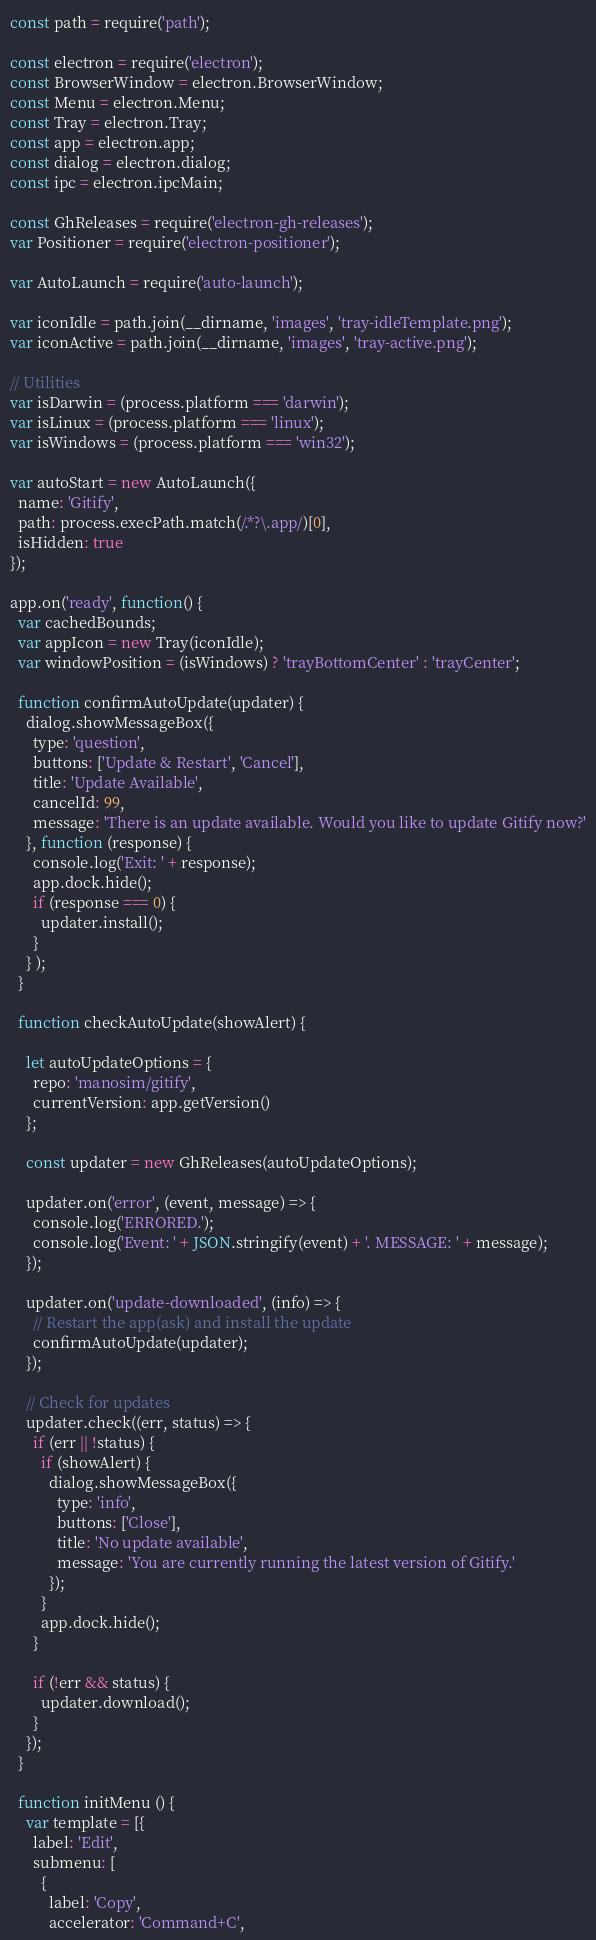Convert code to text. <code><loc_0><loc_0><loc_500><loc_500><_JavaScript_>const path = require('path');

const electron = require('electron');
const BrowserWindow = electron.BrowserWindow;
const Menu = electron.Menu;
const Tray = electron.Tray;
const app = electron.app;
const dialog = electron.dialog;
const ipc = electron.ipcMain;

const GhReleases = require('electron-gh-releases');
var Positioner = require('electron-positioner');

var AutoLaunch = require('auto-launch');

var iconIdle = path.join(__dirname, 'images', 'tray-idleTemplate.png');
var iconActive = path.join(__dirname, 'images', 'tray-active.png');

// Utilities
var isDarwin = (process.platform === 'darwin');
var isLinux = (process.platform === 'linux');
var isWindows = (process.platform === 'win32');

var autoStart = new AutoLaunch({
  name: 'Gitify',
  path: process.execPath.match(/.*?\.app/)[0],
  isHidden: true
});

app.on('ready', function() {
  var cachedBounds;
  var appIcon = new Tray(iconIdle);
  var windowPosition = (isWindows) ? 'trayBottomCenter' : 'trayCenter';

  function confirmAutoUpdate(updater) {
    dialog.showMessageBox({
      type: 'question',
      buttons: ['Update & Restart', 'Cancel'],
      title: 'Update Available',
      cancelId: 99,
      message: 'There is an update available. Would you like to update Gitify now?'
    }, function (response) {
      console.log('Exit: ' + response);
      app.dock.hide();
      if (response === 0) {
        updater.install();
      }
    } );
  }

  function checkAutoUpdate(showAlert) {

    let autoUpdateOptions = {
      repo: 'manosim/gitify',
      currentVersion: app.getVersion()
    };

    const updater = new GhReleases(autoUpdateOptions);

    updater.on('error', (event, message) => {
      console.log('ERRORED.');
      console.log('Event: ' + JSON.stringify(event) + '. MESSAGE: ' + message);
    });

    updater.on('update-downloaded', (info) => {
      // Restart the app(ask) and install the update
      confirmAutoUpdate(updater);
    });

    // Check for updates
    updater.check((err, status) => {
      if (err || !status) {
        if (showAlert) {
          dialog.showMessageBox({
            type: 'info',
            buttons: ['Close'],
            title: 'No update available',
            message: 'You are currently running the latest version of Gitify.'
          });
        }
        app.dock.hide();
      }

      if (!err && status) {
        updater.download();
      }
    });
  }

  function initMenu () {
    var template = [{
      label: 'Edit',
      submenu: [
        {
          label: 'Copy',
          accelerator: 'Command+C',</code> 